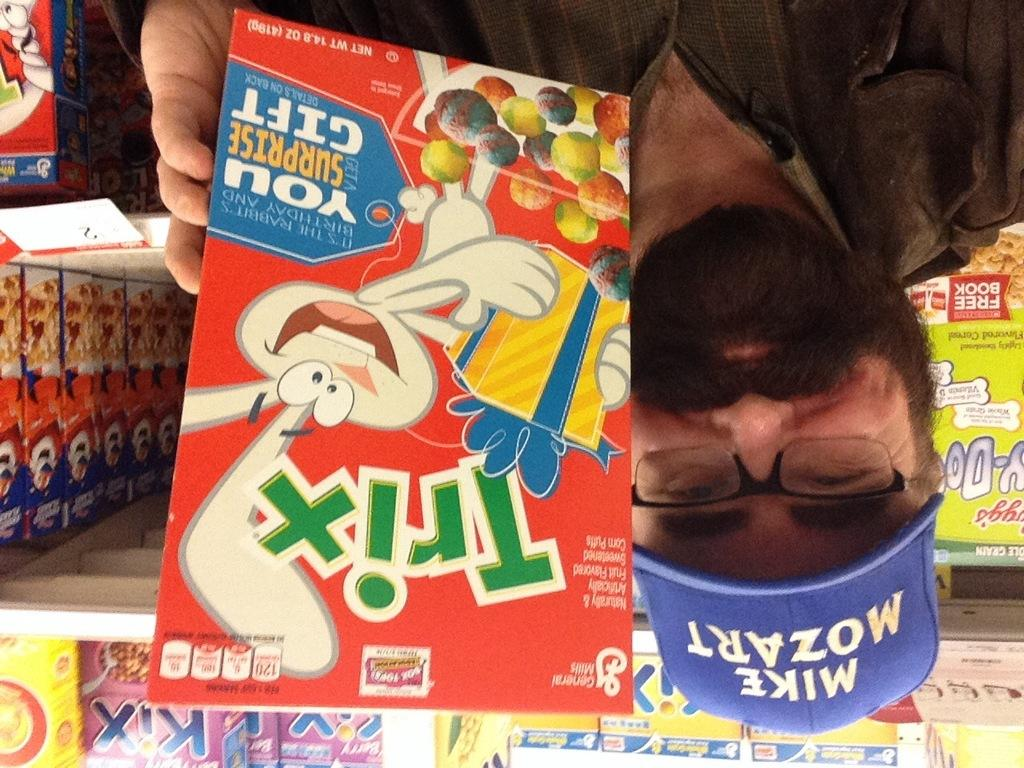What is the man wearing on his head in the image? The man is wearing a cap in the image. What accessory is the man wearing on his face? The man is wearing spectacles in the image. What is the man holding in the image? The man is holding a food box in the image. Can you describe the race that is taking place in the image? There are food boxes in the race, but the specifics of the race are not mentioned in the provided facts. What type of flame can be seen coming from the man's cap in the image? There is no flame present in the image; the man is wearing a cap, but it is not on fire. 